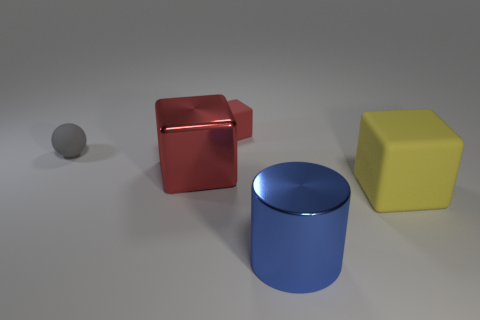Subtract all red blocks. How many blocks are left? 1 Subtract all yellow cubes. How many cubes are left? 2 Subtract all blocks. How many objects are left? 2 Subtract all blue cylinders. How many red blocks are left? 2 Add 2 large red shiny spheres. How many objects exist? 7 Subtract all blue spheres. Subtract all red cylinders. How many spheres are left? 1 Subtract all yellow matte cubes. Subtract all large gray matte blocks. How many objects are left? 4 Add 5 large yellow objects. How many large yellow objects are left? 6 Add 4 red rubber things. How many red rubber things exist? 5 Subtract 1 blue cylinders. How many objects are left? 4 